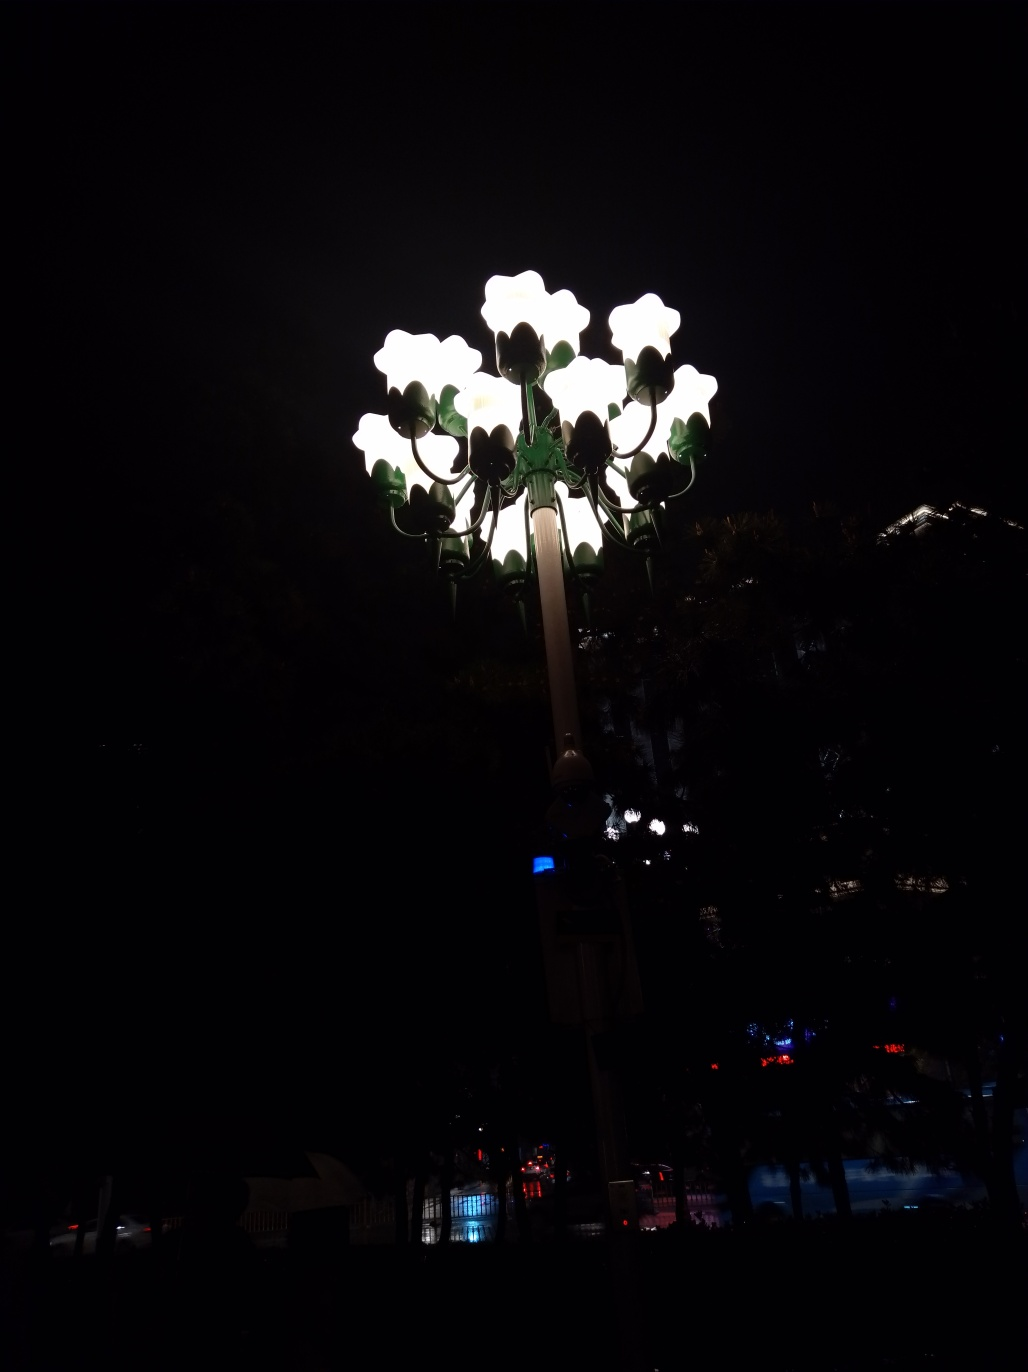What time of day do you think this photo was taken? Based on the darkness surrounding the brightly lit lamps, it appears this photo was taken at night. The ambient light is minimal, which suggests it's well after sunset, likely when artificial lighting like this becomes necessary for visibility. 